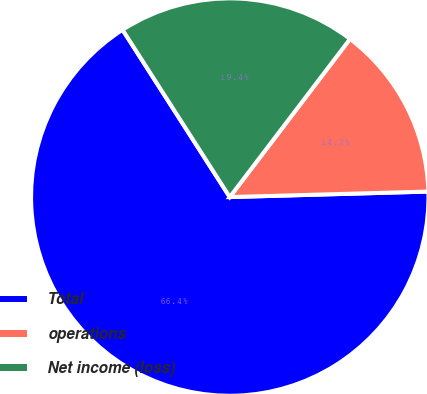Convert chart to OTSL. <chart><loc_0><loc_0><loc_500><loc_500><pie_chart><fcel>Total<fcel>operations<fcel>Net income (loss)<nl><fcel>66.37%<fcel>14.21%<fcel>19.42%<nl></chart> 